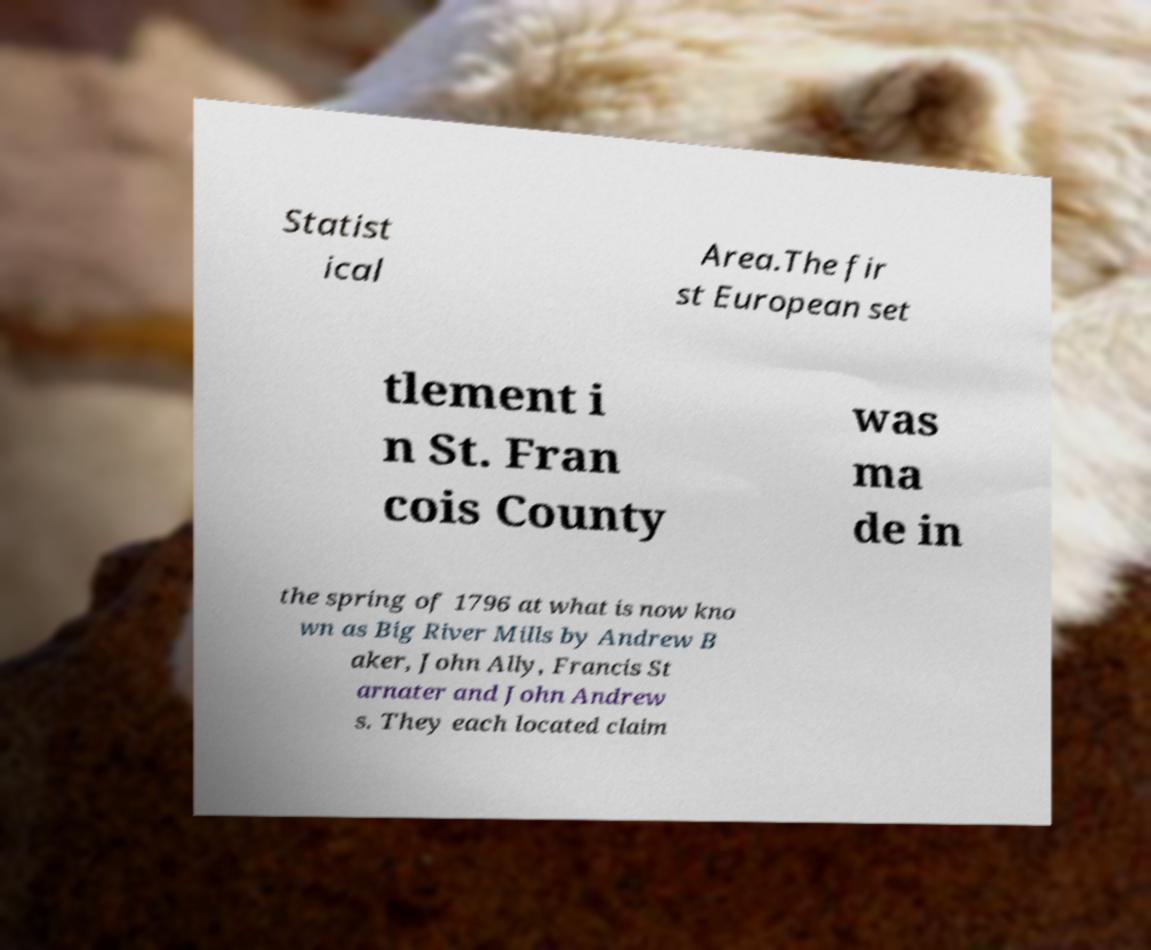Could you assist in decoding the text presented in this image and type it out clearly? Statist ical Area.The fir st European set tlement i n St. Fran cois County was ma de in the spring of 1796 at what is now kno wn as Big River Mills by Andrew B aker, John Ally, Francis St arnater and John Andrew s. They each located claim 